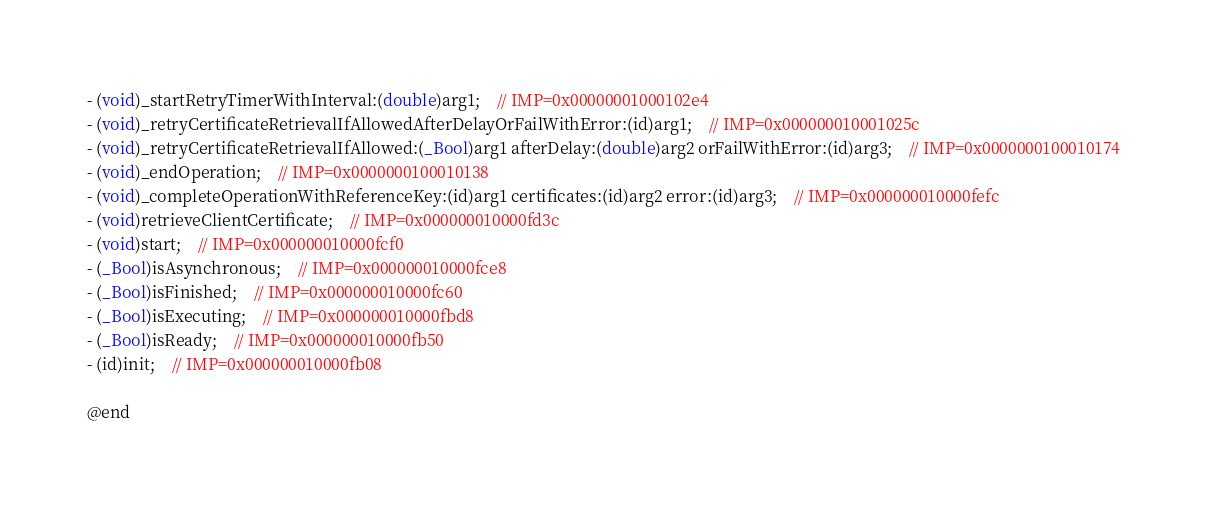<code> <loc_0><loc_0><loc_500><loc_500><_C_>- (void)_startRetryTimerWithInterval:(double)arg1;	// IMP=0x00000001000102e4
- (void)_retryCertificateRetrievalIfAllowedAfterDelayOrFailWithError:(id)arg1;	// IMP=0x000000010001025c
- (void)_retryCertificateRetrievalIfAllowed:(_Bool)arg1 afterDelay:(double)arg2 orFailWithError:(id)arg3;	// IMP=0x0000000100010174
- (void)_endOperation;	// IMP=0x0000000100010138
- (void)_completeOperationWithReferenceKey:(id)arg1 certificates:(id)arg2 error:(id)arg3;	// IMP=0x000000010000fefc
- (void)retrieveClientCertificate;	// IMP=0x000000010000fd3c
- (void)start;	// IMP=0x000000010000fcf0
- (_Bool)isAsynchronous;	// IMP=0x000000010000fce8
- (_Bool)isFinished;	// IMP=0x000000010000fc60
- (_Bool)isExecuting;	// IMP=0x000000010000fbd8
- (_Bool)isReady;	// IMP=0x000000010000fb50
- (id)init;	// IMP=0x000000010000fb08

@end

</code> 